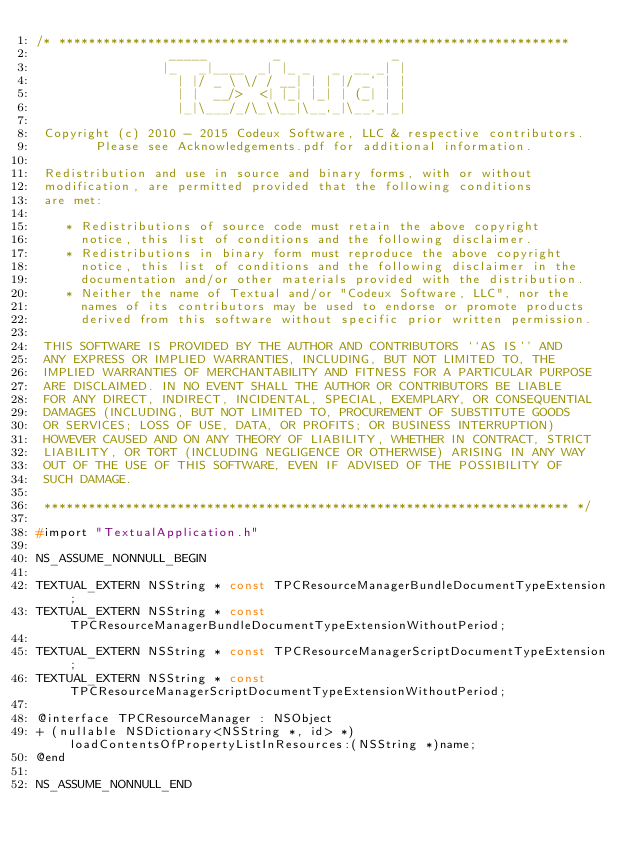Convert code to text. <code><loc_0><loc_0><loc_500><loc_500><_C_>/* ********************************************************************* 
                  _____         _               _
                 |_   _|____  _| |_ _   _  __ _| |
                   | |/ _ \ \/ / __| | | |/ _` | |
                   | |  __/>  <| |_| |_| | (_| | |
                   |_|\___/_/\_\\__|\__,_|\__,_|_|

 Copyright (c) 2010 - 2015 Codeux Software, LLC & respective contributors.
        Please see Acknowledgements.pdf for additional information.

 Redistribution and use in source and binary forms, with or without
 modification, are permitted provided that the following conditions
 are met:

    * Redistributions of source code must retain the above copyright
      notice, this list of conditions and the following disclaimer.
    * Redistributions in binary form must reproduce the above copyright
      notice, this list of conditions and the following disclaimer in the
      documentation and/or other materials provided with the distribution.
    * Neither the name of Textual and/or "Codeux Software, LLC", nor the 
      names of its contributors may be used to endorse or promote products 
      derived from this software without specific prior written permission.

 THIS SOFTWARE IS PROVIDED BY THE AUTHOR AND CONTRIBUTORS ``AS IS'' AND
 ANY EXPRESS OR IMPLIED WARRANTIES, INCLUDING, BUT NOT LIMITED TO, THE
 IMPLIED WARRANTIES OF MERCHANTABILITY AND FITNESS FOR A PARTICULAR PURPOSE
 ARE DISCLAIMED. IN NO EVENT SHALL THE AUTHOR OR CONTRIBUTORS BE LIABLE
 FOR ANY DIRECT, INDIRECT, INCIDENTAL, SPECIAL, EXEMPLARY, OR CONSEQUENTIAL
 DAMAGES (INCLUDING, BUT NOT LIMITED TO, PROCUREMENT OF SUBSTITUTE GOODS
 OR SERVICES; LOSS OF USE, DATA, OR PROFITS; OR BUSINESS INTERRUPTION)
 HOWEVER CAUSED AND ON ANY THEORY OF LIABILITY, WHETHER IN CONTRACT, STRICT
 LIABILITY, OR TORT (INCLUDING NEGLIGENCE OR OTHERWISE) ARISING IN ANY WAY
 OUT OF THE USE OF THIS SOFTWARE, EVEN IF ADVISED OF THE POSSIBILITY OF
 SUCH DAMAGE.

 *********************************************************************** */

#import "TextualApplication.h"

NS_ASSUME_NONNULL_BEGIN

TEXTUAL_EXTERN NSString * const TPCResourceManagerBundleDocumentTypeExtension;
TEXTUAL_EXTERN NSString * const TPCResourceManagerBundleDocumentTypeExtensionWithoutPeriod;

TEXTUAL_EXTERN NSString * const TPCResourceManagerScriptDocumentTypeExtension;
TEXTUAL_EXTERN NSString * const TPCResourceManagerScriptDocumentTypeExtensionWithoutPeriod;

@interface TPCResourceManager : NSObject
+ (nullable NSDictionary<NSString *, id> *)loadContentsOfPropertyListInResources:(NSString *)name;
@end

NS_ASSUME_NONNULL_END
</code> 